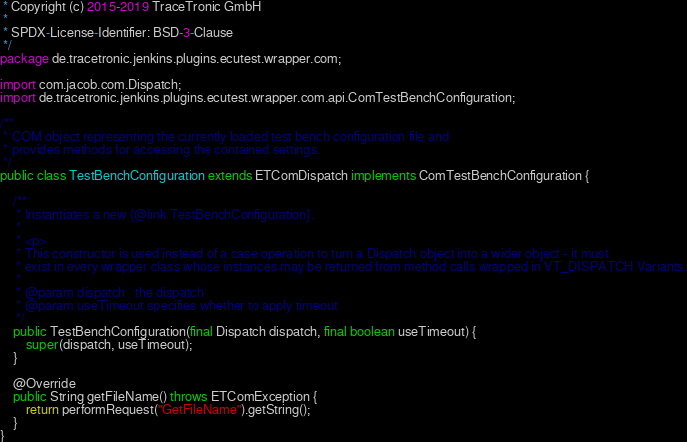Convert code to text. <code><loc_0><loc_0><loc_500><loc_500><_Java_> * Copyright (c) 2015-2019 TraceTronic GmbH
 *
 * SPDX-License-Identifier: BSD-3-Clause
 */
package de.tracetronic.jenkins.plugins.ecutest.wrapper.com;

import com.jacob.com.Dispatch;
import de.tracetronic.jenkins.plugins.ecutest.wrapper.com.api.ComTestBenchConfiguration;

/**
 * COM object representing the currently loaded test bench configuration file and
 * provides methods for accessing the contained settings.
 */
public class TestBenchConfiguration extends ETComDispatch implements ComTestBenchConfiguration {

    /**
     * Instantiates a new {@link TestBenchConfiguration}.
     *
     * <p>
     * This constructor is used instead of a case operation to turn a Dispatch object into a wider object - it must
     * exist in every wrapper class whose instances may be returned from method calls wrapped in VT_DISPATCH Variants.
     *
     * @param dispatch   the dispatch
     * @param useTimeout specifies whether to apply timeout
     */
    public TestBenchConfiguration(final Dispatch dispatch, final boolean useTimeout) {
        super(dispatch, useTimeout);
    }

    @Override
    public String getFileName() throws ETComException {
        return performRequest("GetFileName").getString();
    }
}
</code> 